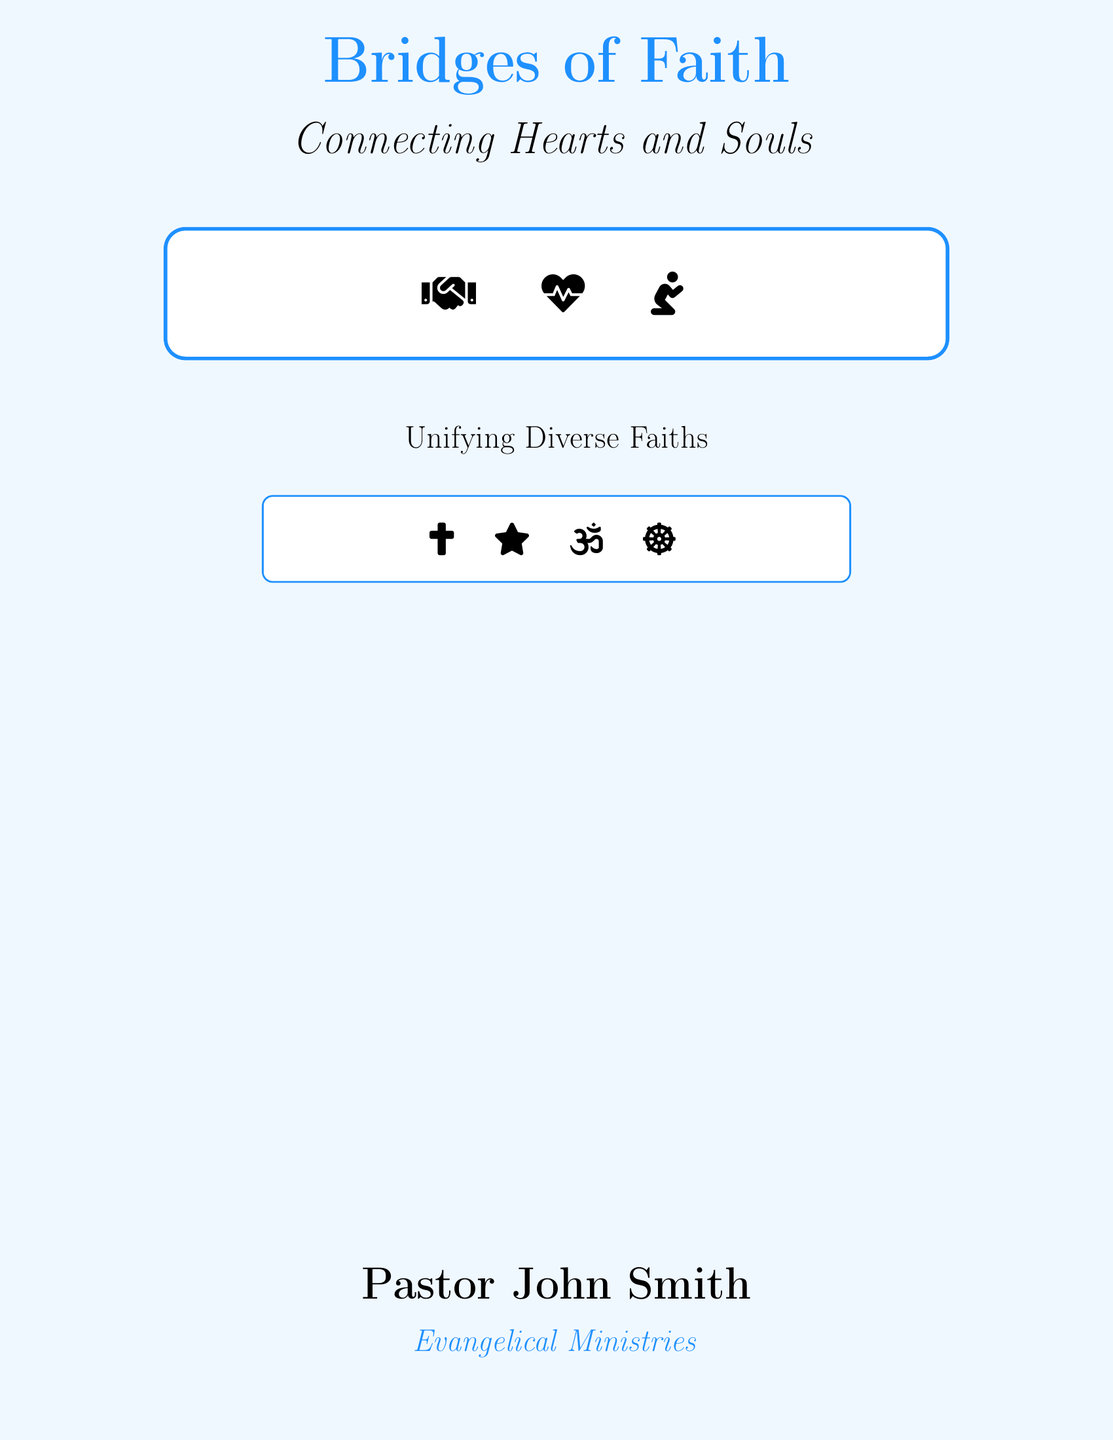What is the title of the book? The title is prominently displayed at the top of the cover.
Answer: Bridges of Faith Who is the author of the book? The author's name is listed at the bottom of the cover.
Answer: Pastor John Smith What is the subtitle of the book? The subtitle is located below the title, emphasizing the theme of connection.
Answer: Connecting Hearts and Souls What symbols are included on the cover? The cover contains multiple religious symbols that represent various faiths.
Answer: Cross, Star, Om, Dharmachakra What color is used for the background of the cover? The background color is specified in the design of the cover.
Answer: Light blue How many symbols are showcased in the box below the title? The count of unified symbols indicates diversity in faith underlines the book's theme.
Answer: Three What theme does the subtitle imply? The subtitle suggests an exploration of the core message of unity in faith.
Answer: Unifying Diverse Faiths 